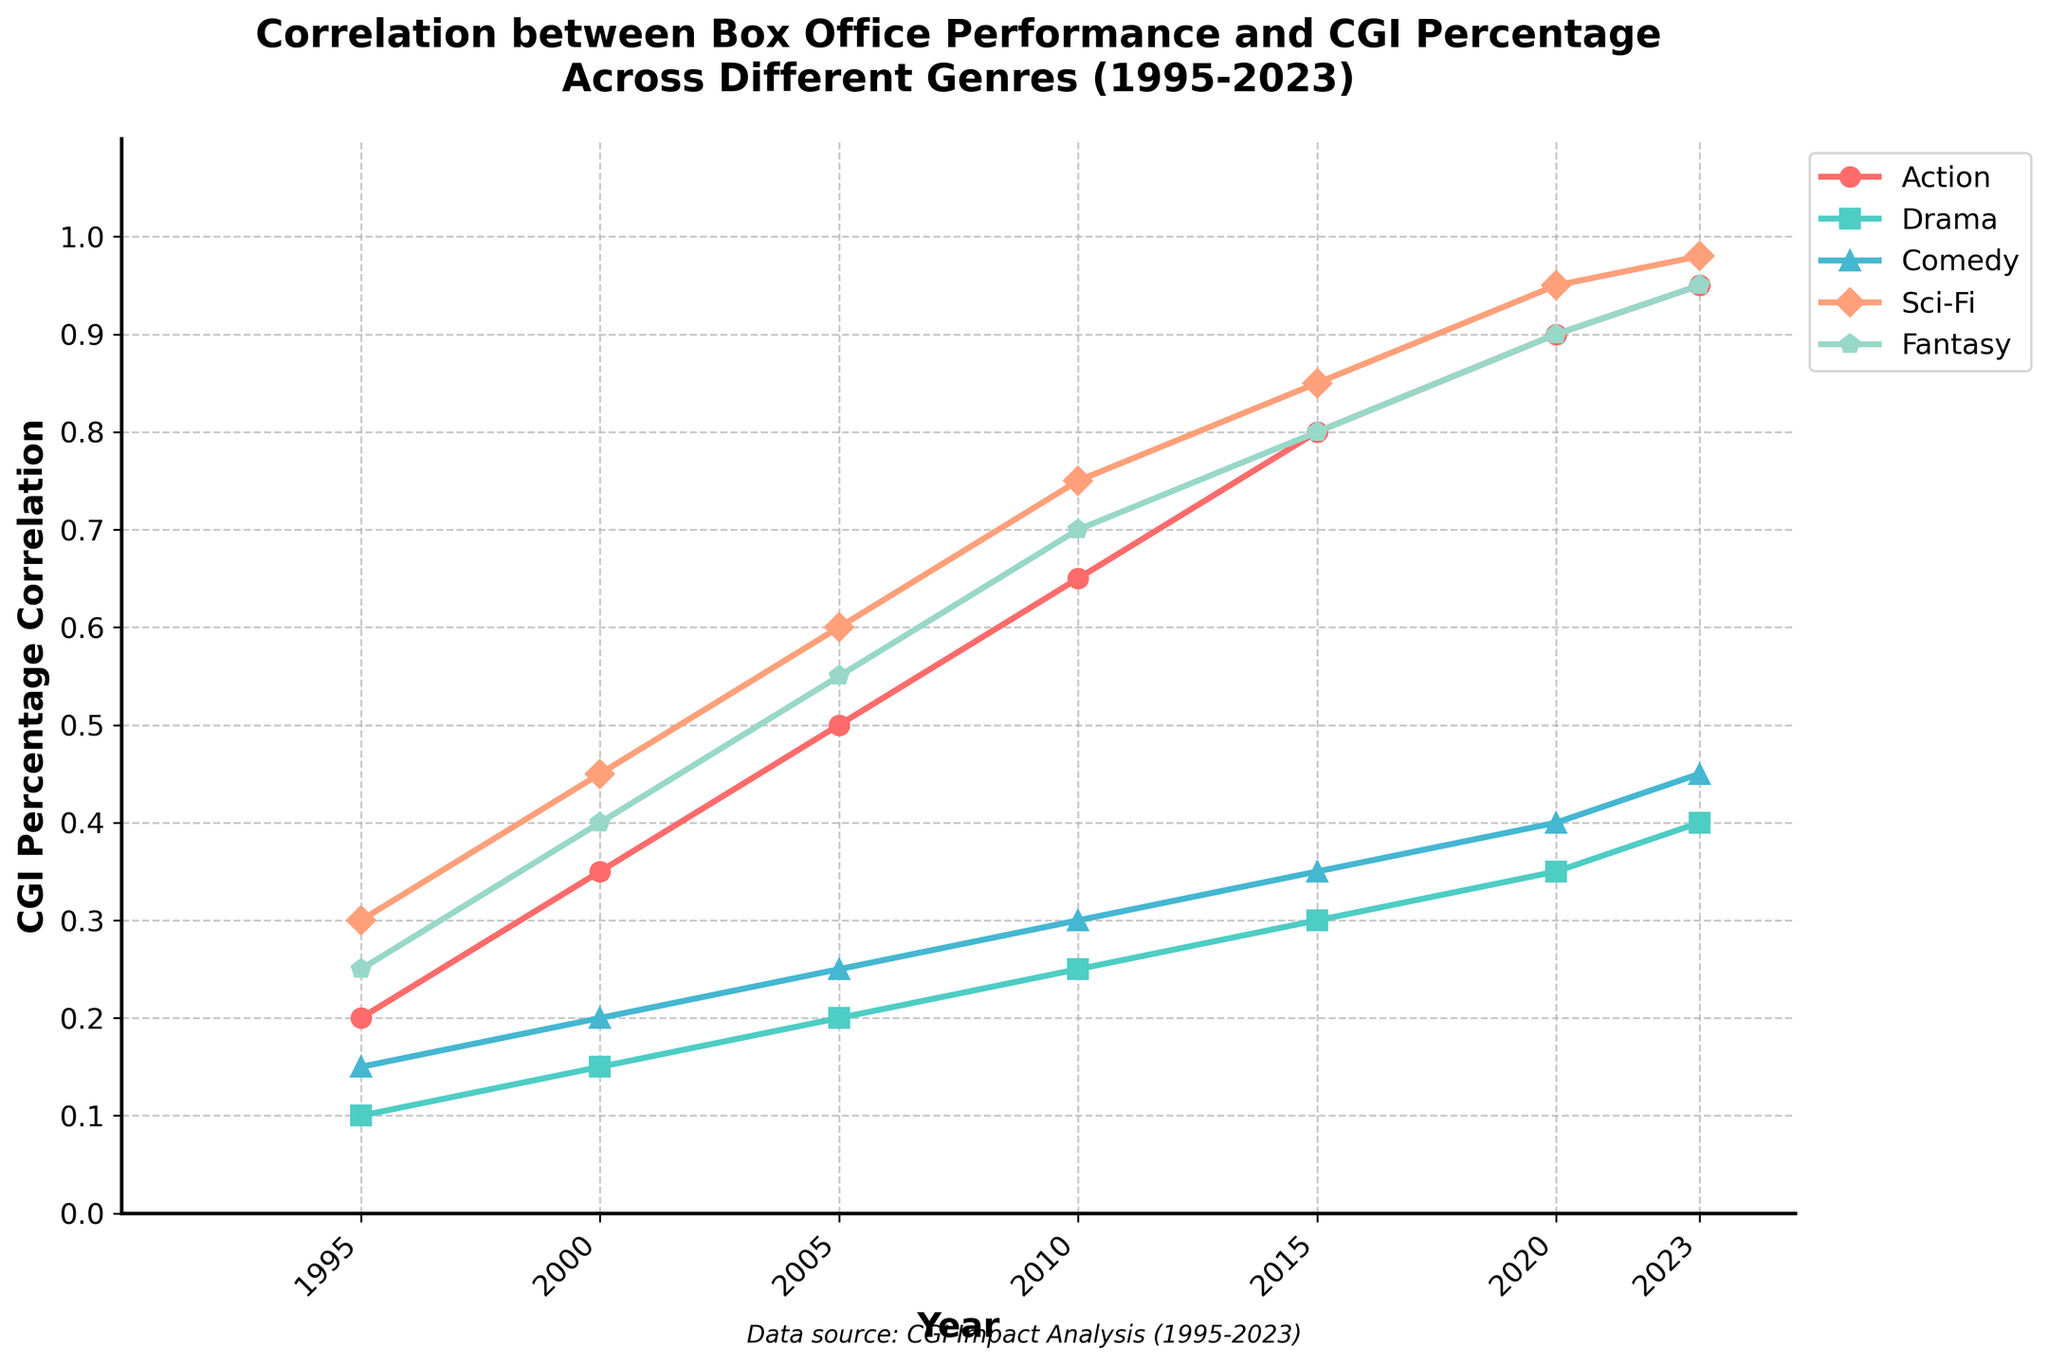How has the correlation between box office performance and CGI percentage in Drama movies changed from 1995 to 2023? The Drama genre's CGI percentage correlation starts at 0.1 in 1995, increasing to 0.15 in 2000, 0.2 in 2005, 0.25 in 2010, 0.3 in 2015, 0.35 in 2020, and reaching 0.4 in 2023. The trend shows a gradual increase over the period.
Answer: Increased from 0.1 to 0.4 Which genre consistently shows the highest correlation between box office performance and CGI percentage from 1995 to 2023? By examining the graph, Sci-Fi consistently shows the highest correlation values from 1995 (0.3) through 2023 (0.98). No other genre reaches as high values across the years.
Answer: Sci-Fi In which year did the Action genre see the most significant increase in CGI percentage correlation? To find the most significant increase, we need to compare year-to-year differences. Between 2005 and 2010, the correlation increases from 0.5 to 0.65, the most significant jump of 0.15 over any other period.
Answer: 2010 What is the difference in CGI percentage correlation between Sci-Fi and Comedy genres in 2023? In 2023, Sci-Fi has a CGI percentage correlation of 0.98, and Comedy has 0.45. The difference is calculated as 0.98 - 0.45 = 0.53.
Answer: 0.53 Across all genres, what is the average CGI percentage correlation in 2005? For 2005, sum all percentages: (0.5 Action + 0.2 Drama + 0.25 Comedy + 0.6 Sci-Fi + 0.55 Fantasy) = 2.1. The average is 2.1 / 5 genres = 0.42.
Answer: 0.42 In which year do all genres have their lowest CGI percentage correlation values? By checking each genre's correlation year by year, the lowest values for all genres occur in 1995: Action (0.2), Drama (0.1), Comedy (0.15), Sci-Fi (0.3), Fantasy (0.25).
Answer: 1995 What trend do we observe for Fantasy genre's correlation from 2015 to 2023? For Fantasy, the CGI percentage correlation increases from 0.8 (2015) to 0.9 (2020), and then slightly to 0.95 (2023). The trend is consistently increasing.
Answer: Increasing Which genre has the least increase in CGI percentage correlation from 1995 to 2023? Drama increases from 0.1 in 1995 to 0.4 in 2023, a total increase of 0.3, which is the smallest increment compared to other genres.
Answer: Drama What is the combined CGI percentage correlation increase for Action and Fantasy genres from 1995 to 2023? Action increases from 0.2 (1995) to 0.95 (2023), giving 0.95 - 0.2 = 0.75. Fantasy increases from 0.25 (1995) to 0.95 (2023), giving 0.95 - 0.25 = 0.7. The combined increase is 0.75 + 0.7 = 1.45.
Answer: 1.45 